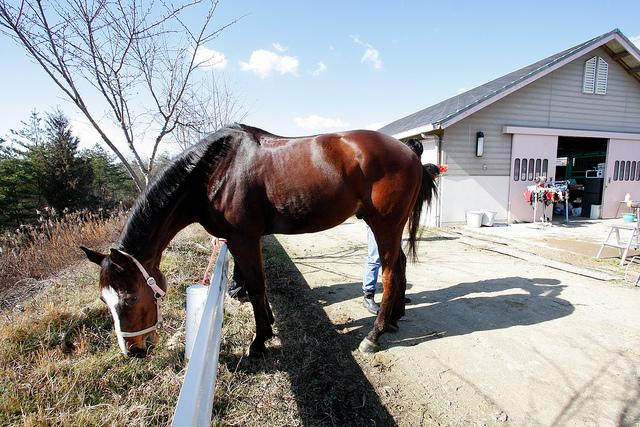Is the horse behind a fence?
Answer briefly. Yes. Is the horse going to eat the hay?
Concise answer only. Yes. How many horses can be seen?
Keep it brief. 1. What color is the horse?
Answer briefly. Brown. 